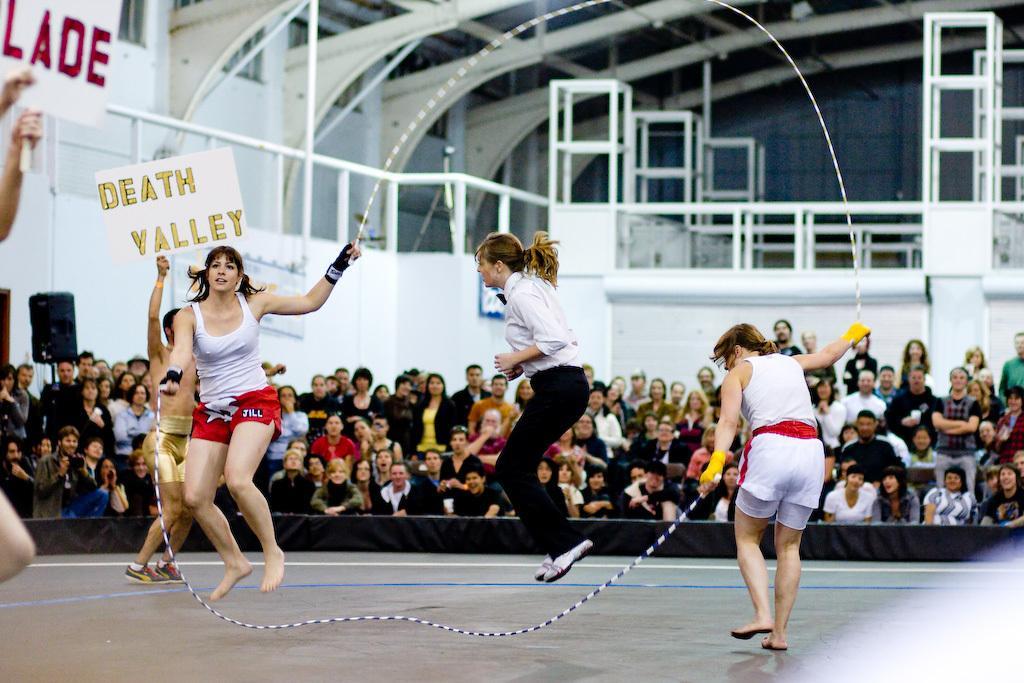In one or two sentences, can you explain what this image depicts? In this picture we can see a group of people,some people are holding name boards and in the background we can see rods,roof. 